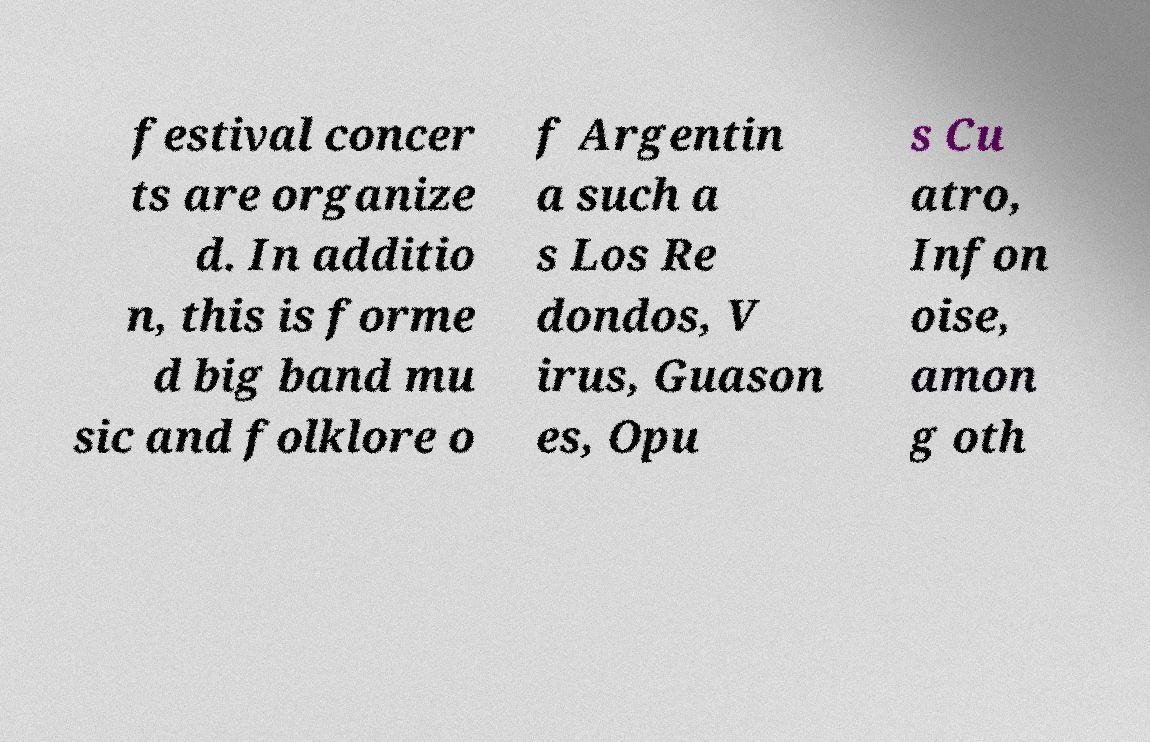Can you accurately transcribe the text from the provided image for me? festival concer ts are organize d. In additio n, this is forme d big band mu sic and folklore o f Argentin a such a s Los Re dondos, V irus, Guason es, Opu s Cu atro, Infon oise, amon g oth 